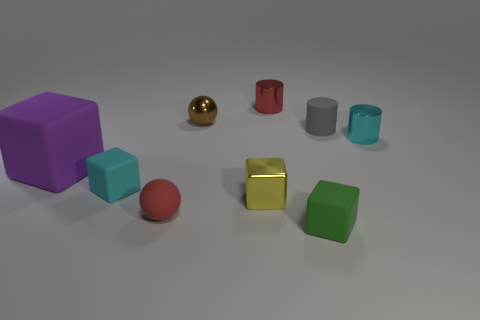Subtract all gray cubes. Subtract all purple balls. How many cubes are left? 4 Add 1 red metal cylinders. How many objects exist? 10 Subtract all cylinders. How many objects are left? 6 Add 1 green rubber things. How many green rubber things are left? 2 Add 8 big brown cubes. How many big brown cubes exist? 8 Subtract 0 red cubes. How many objects are left? 9 Subtract all gray things. Subtract all yellow cubes. How many objects are left? 7 